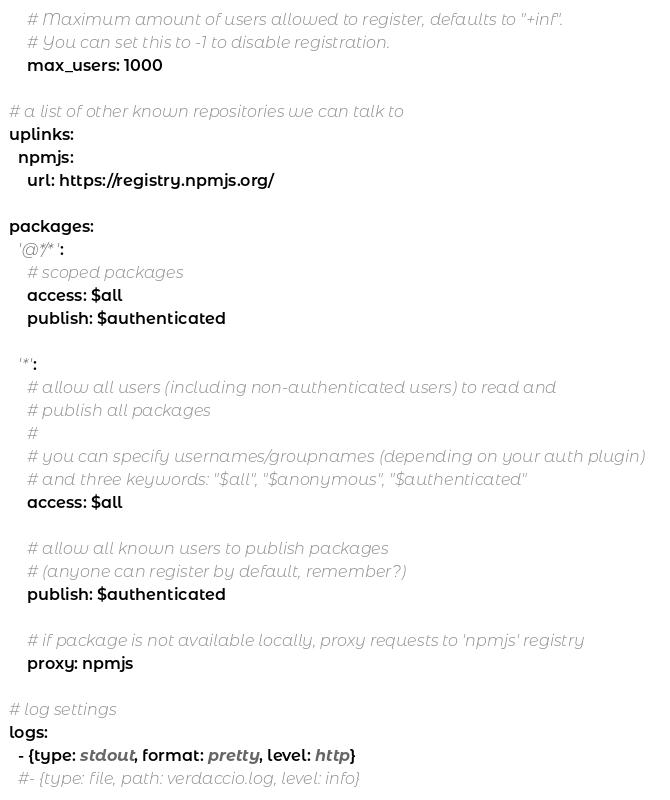<code> <loc_0><loc_0><loc_500><loc_500><_YAML_>    # Maximum amount of users allowed to register, defaults to "+inf".
    # You can set this to -1 to disable registration.
    max_users: 1000

# a list of other known repositories we can talk to
uplinks:
  npmjs:
    url: https://registry.npmjs.org/

packages:
  '@*/*':
    # scoped packages
    access: $all
    publish: $authenticated

  '*':
    # allow all users (including non-authenticated users) to read and
    # publish all packages
    #
    # you can specify usernames/groupnames (depending on your auth plugin)
    # and three keywords: "$all", "$anonymous", "$authenticated"
    access: $all

    # allow all known users to publish packages
    # (anyone can register by default, remember?)
    publish: $authenticated

    # if package is not available locally, proxy requests to 'npmjs' registry
    proxy: npmjs

# log settings
logs:
  - {type: stdout, format: pretty, level: http}
  #- {type: file, path: verdaccio.log, level: info}
</code> 